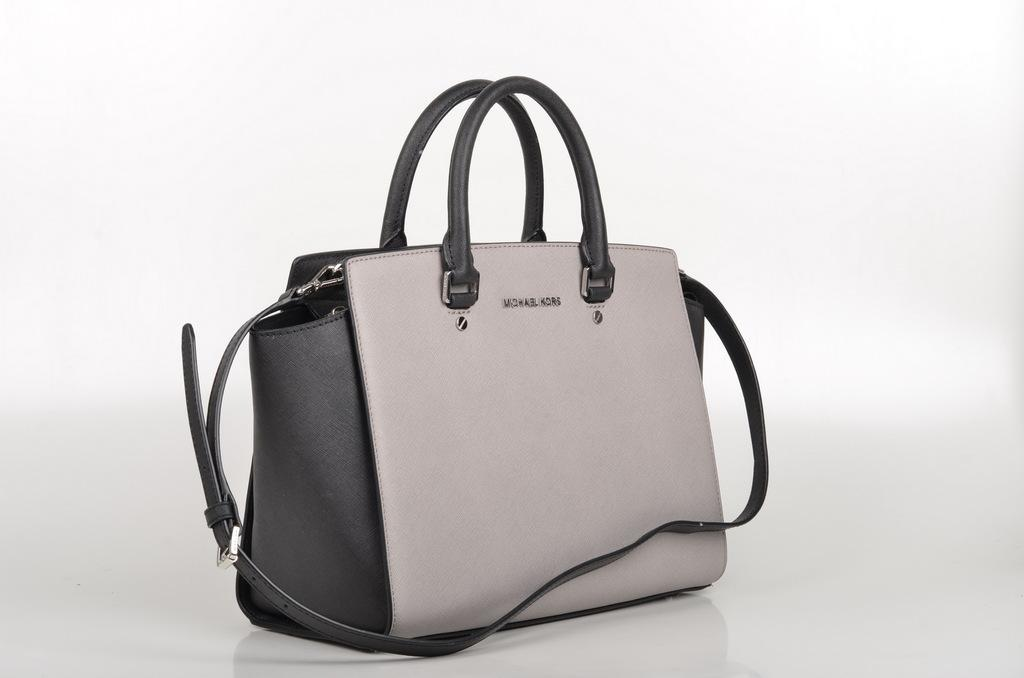What object can be seen in the image? There is a purse in the image. What is the color of the purse? The purse is in ash color. What is the color of the handles on the purse? The handles of the purse are in black color. What type of music can be heard coming from the stranger in the image? There is no stranger or music present in the image, so it's not possible to determine what, if any, music might be heard. 